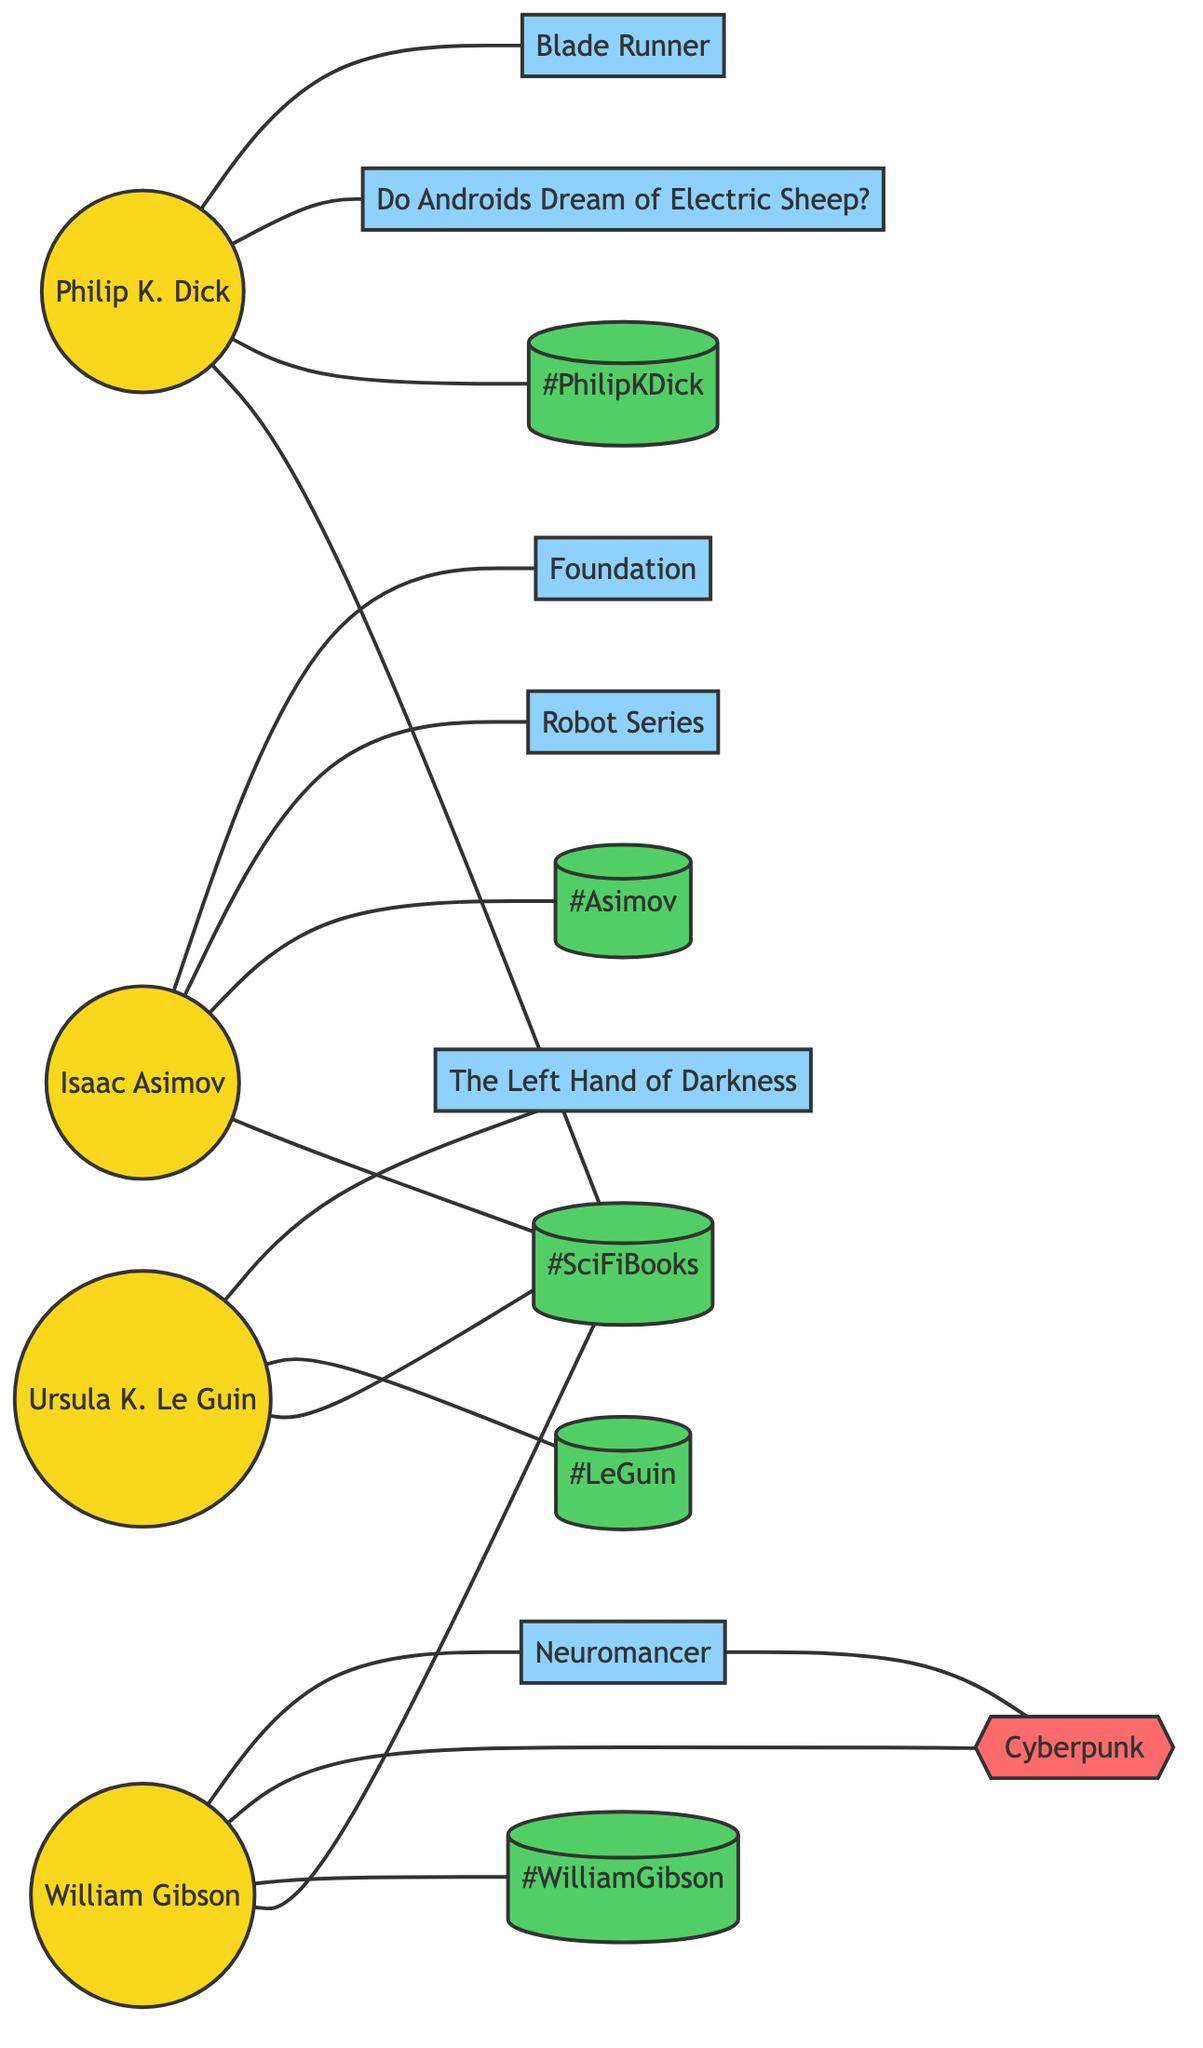What is the total number of authors represented in the diagram? The diagram contains four distinct nodes that represent authors: Philip K. Dick, Isaac Asimov, Ursula K. Le Guin, and William Gibson. Counting these nodes gives a total of four authors.
Answer: 4 Which book is connected to Philip K. Dick? The diagram shows two books connected to Philip K. Dick: 'Blade Runner' and 'Do Androids Dream of Electric Sheep?'. Both books are directly linked to his node.
Answer: Blade Runner, Do Androids Dream of Electric Sheep? How many books are associated with Isaac Asimov? Isaac Asimov is linked to two books: 'Foundation' and 'Robot Series', as evident from the connections from his node to these book nodes.
Answer: 2 Which genre is linked to Neuromancer? Neuromancer has a connection with the genre 'Cyberpunk' in the diagram, making it the related genre. This is indicated by the edge connecting Neuromancer to the Cyberpunk node.
Answer: Cyberpunk How many total edges connect the authors to their works and hashtags? The diagram features a total of 14 edges connecting authors to their respective works and hashtags. By counting each edge, we find there are 14 connections in total.
Answer: 14 Which author is connected to the hashtag #LeGuin? The node for Ursula K. Le Guin has a direct edge linking to the hashtag #LeGuin, indicating that she is the author associated with this hashtag in the diagram.
Answer: Ursula K. Le Guin Identify the books written by William Gibson. The diagram shows that William Gibson is connected by edges to 'Neuromancer' and 'Cyberpunk', indicating these two are the works associated with him.
Answer: Neuromancer, Cyberpunk Which hashtags are linked to Philip K. Dick? Philip K. Dick is connected to three hashtags: #PhilipKDick, #SciFiBooks, and so forth, as seen from the edges connecting his node to these hashtags.
Answer: #PhilipKDick, #SciFiBooks Which author has the most works mentioned in the diagram? Analyzing the connections of the authors, Philip K. Dick has two known works, while Isaac Asimov has two, Ursula K. Le Guin has one, and William Gibson has one too; hence, maximum works are two for Philip K. Dick and Isaac Asimov.
Answer: Philip K. Dick, Isaac Asimov 